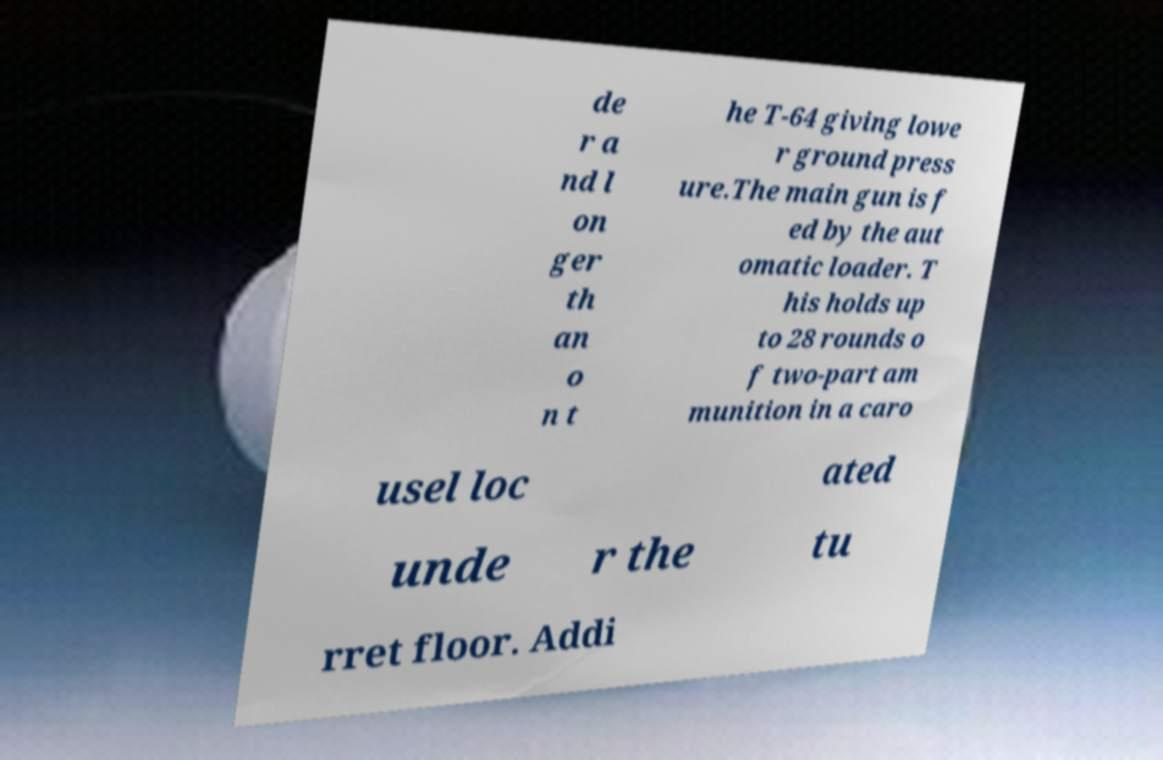Please read and relay the text visible in this image. What does it say? de r a nd l on ger th an o n t he T-64 giving lowe r ground press ure.The main gun is f ed by the aut omatic loader. T his holds up to 28 rounds o f two-part am munition in a caro usel loc ated unde r the tu rret floor. Addi 